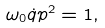<formula> <loc_0><loc_0><loc_500><loc_500>\omega _ { 0 } \dot { q } p ^ { 2 } = 1 ,</formula> 